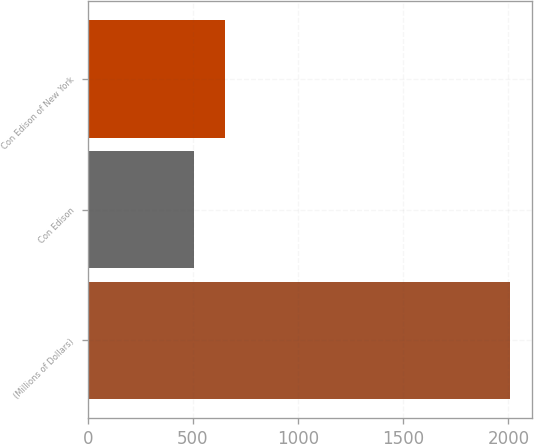Convert chart to OTSL. <chart><loc_0><loc_0><loc_500><loc_500><bar_chart><fcel>(Millions of Dollars)<fcel>Con Edison<fcel>Con Edison of New York<nl><fcel>2010<fcel>504<fcel>654.6<nl></chart> 